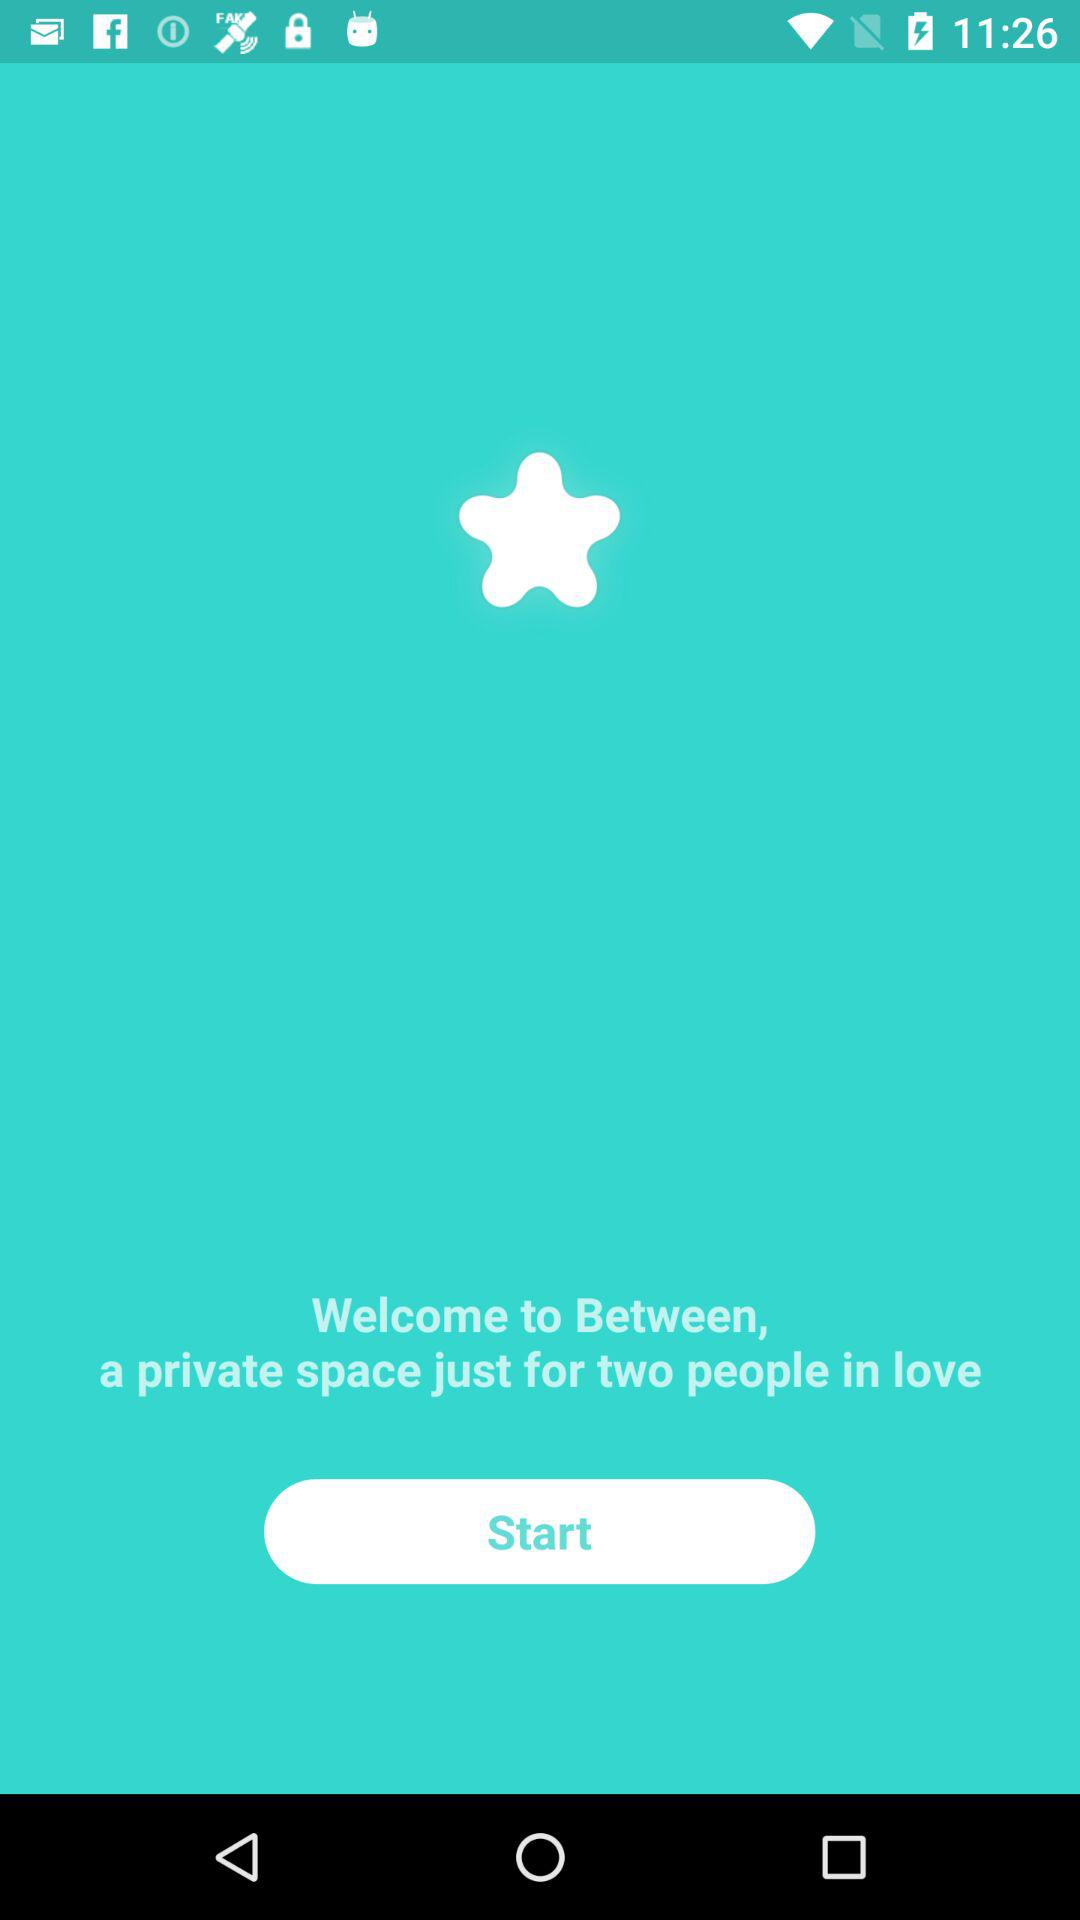What is the name of the application? The name of the application is "Between". 